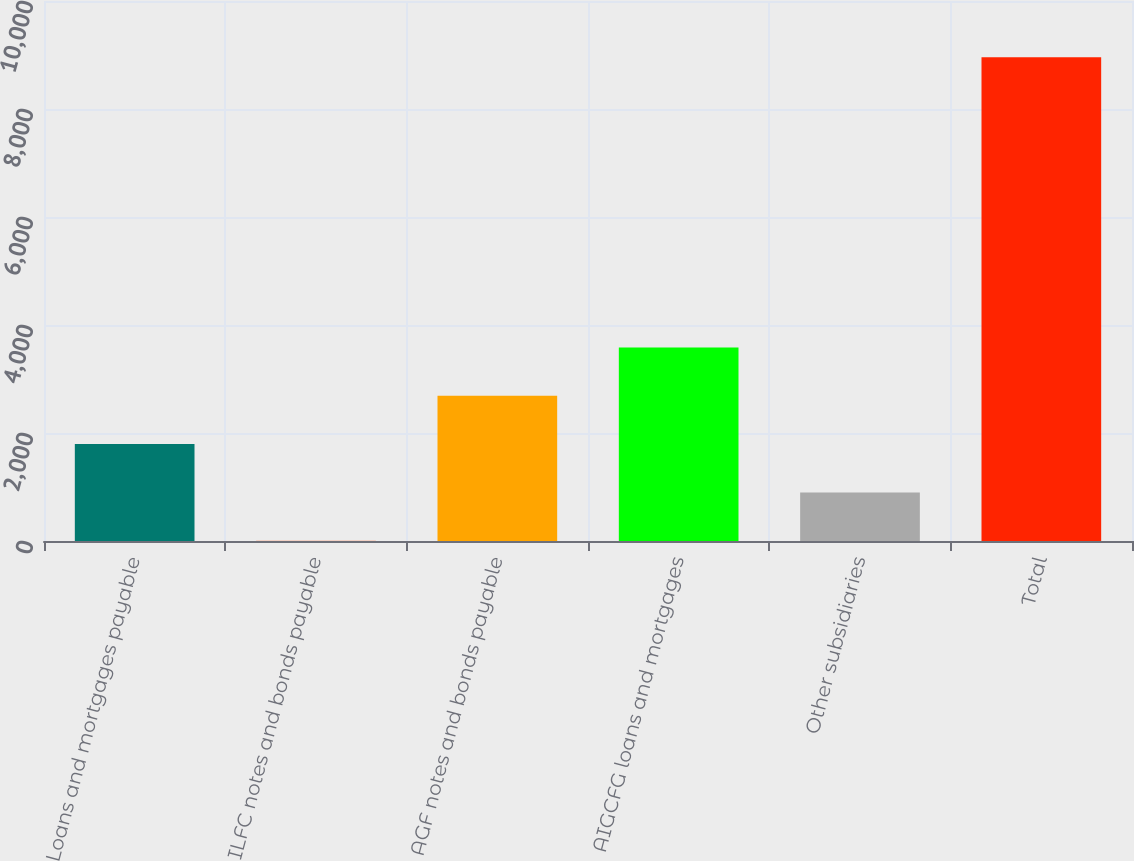Convert chart to OTSL. <chart><loc_0><loc_0><loc_500><loc_500><bar_chart><fcel>Loans and mortgages payable<fcel>ILFC notes and bonds payable<fcel>AGF notes and bonds payable<fcel>AIGCFG loans and mortgages<fcel>Other subsidiaries<fcel>Total<nl><fcel>1794.2<fcel>3<fcel>2689.8<fcel>3585.4<fcel>898.6<fcel>8959<nl></chart> 